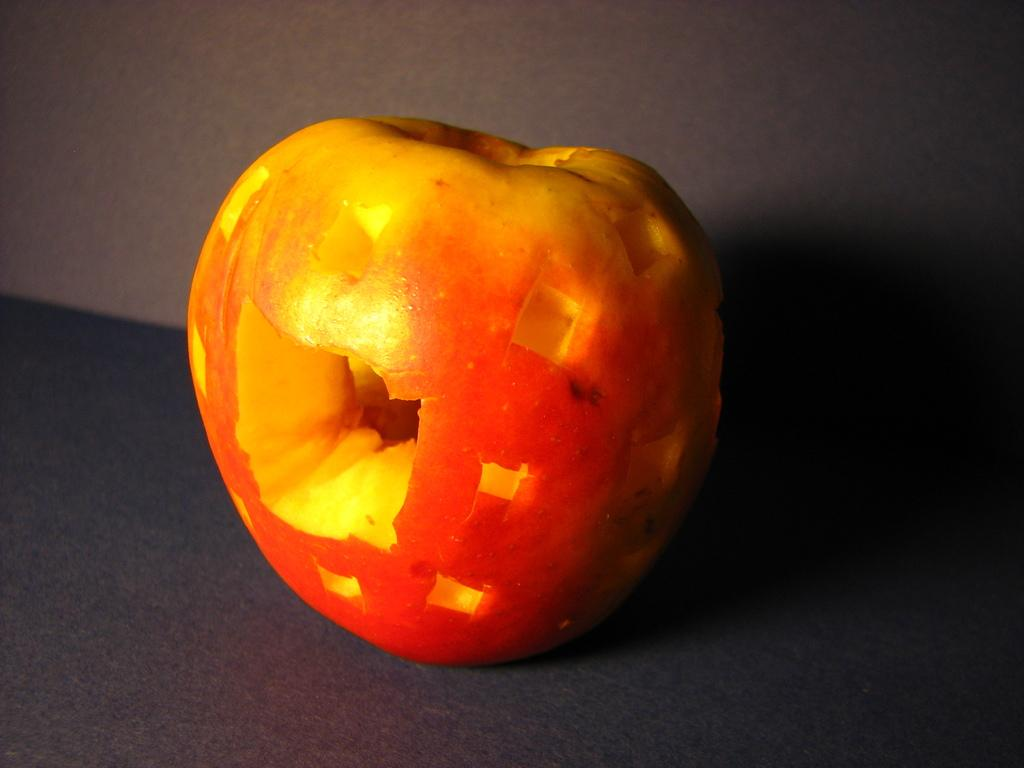What type of food item is present in the image? There is a fruit in the image. Where is the fruit located? The fruit is on a platform. What can be seen in the background of the image? There is a wall in the background of the image. How many visitors can be seen interacting with the fruit in the image? There are no visitors present in the image; it only features a fruit on a platform. What type of company is associated with the fruit in the image? There is no company associated with the fruit in the image; it is simply a fruit on a platform. 